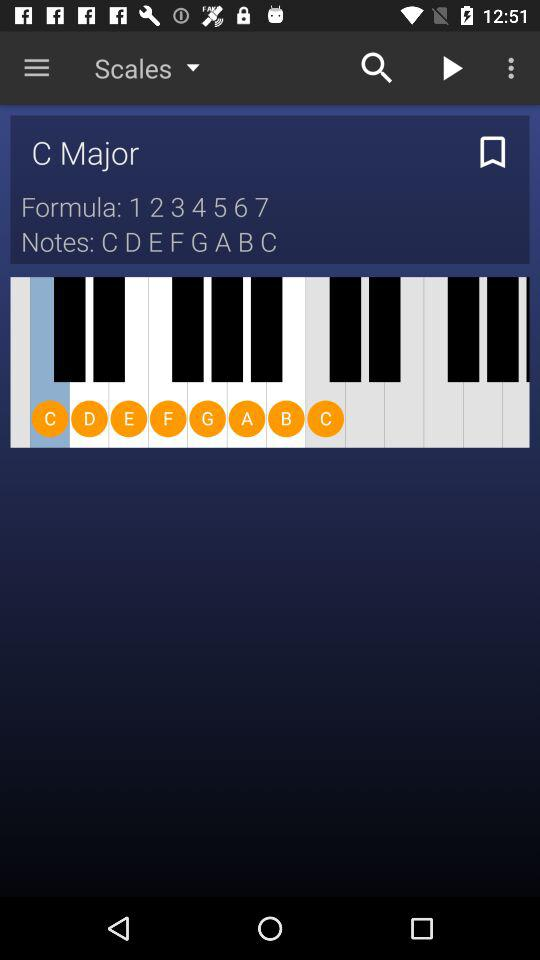What is the formula? The formula is "1 2 3 4 5 6 7 ". 